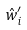Convert formula to latex. <formula><loc_0><loc_0><loc_500><loc_500>\hat { w } _ { i } ^ { \prime }</formula> 